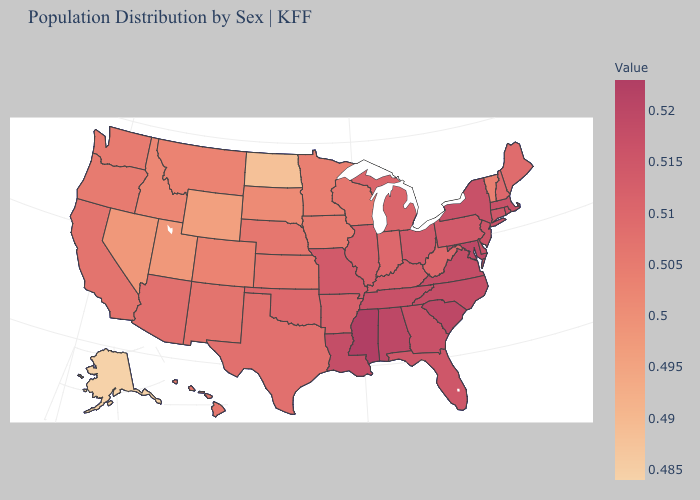Among the states that border Arkansas , does Texas have the lowest value?
Be succinct. Yes. Among the states that border Wyoming , which have the lowest value?
Quick response, please. Utah. Among the states that border South Dakota , does Nebraska have the lowest value?
Write a very short answer. No. Which states hav the highest value in the MidWest?
Short answer required. Missouri, Ohio. Which states have the lowest value in the USA?
Write a very short answer. Alaska. 